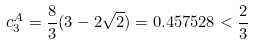<formula> <loc_0><loc_0><loc_500><loc_500>c _ { 3 } ^ { A } = \frac { 8 } { 3 } ( 3 - 2 \sqrt { 2 } ) = 0 . 4 5 7 5 2 8 < \frac { 2 } { 3 }</formula> 